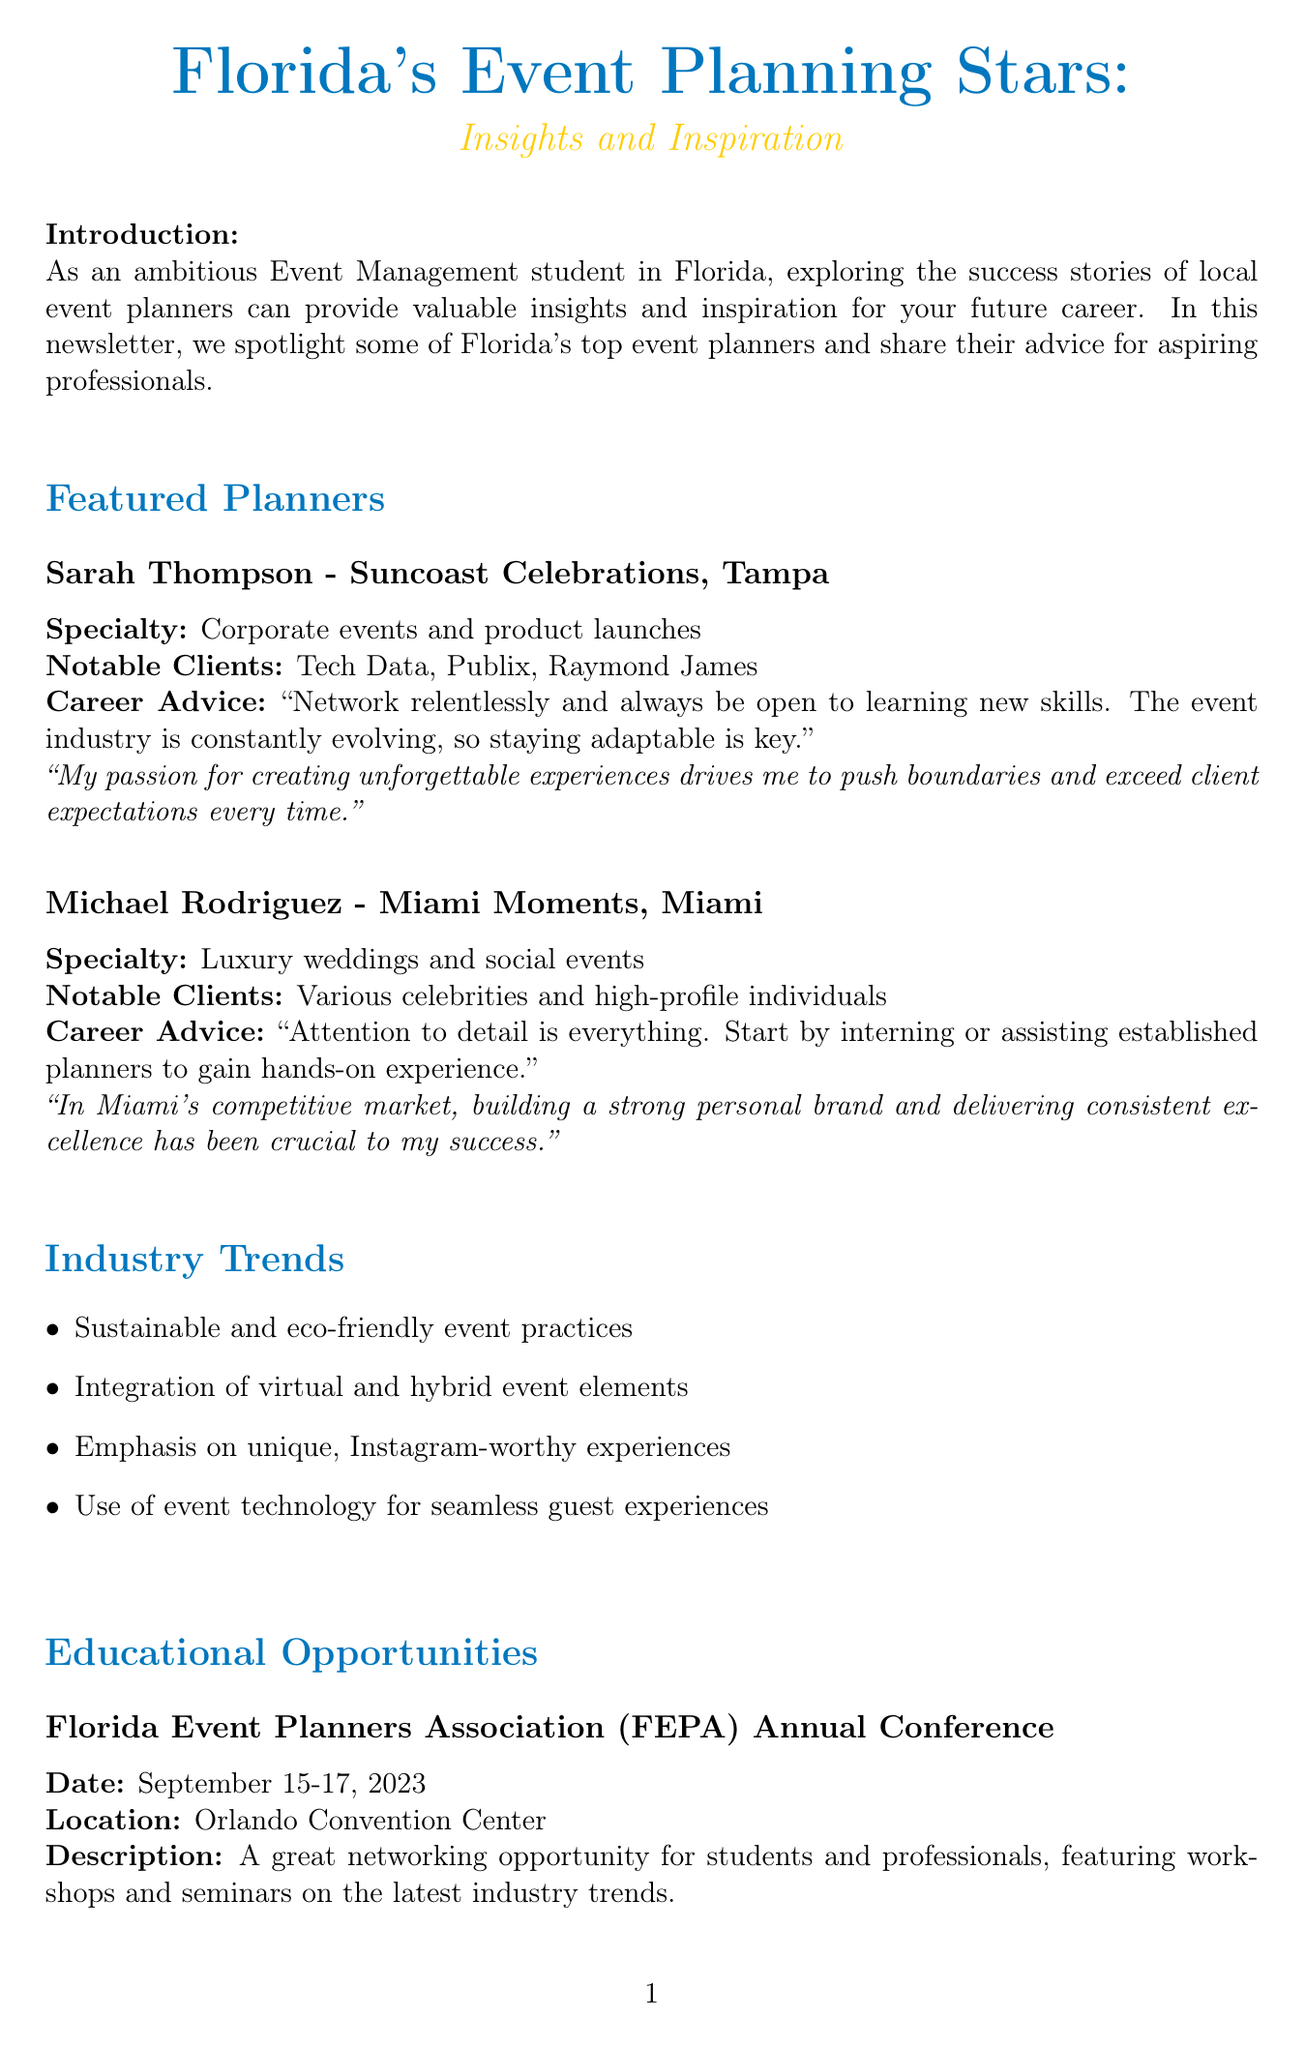What is the title of the newsletter? The title of the newsletter is provided at the beginning of the document.
Answer: Florida's Event Planning Stars: Insights and Inspiration Who is the owner of Suncoast Celebrations? The document specifies the owner of Suncoast Celebrations as Sarah Thompson.
Answer: Sarah Thompson What is Michael Rodriguez's specialty? The document lists Michael Rodriguez's specialty under his section.
Answer: Luxury weddings and social events When is the Florida Event Planners Association Annual Conference taking place? The date of the conference is explicitly mentioned in the educational opportunities section.
Answer: September 15-17, 2023 What key trend emphasizes unique experiences for social media? The document outlines several industry trends, one of which focuses on social media.
Answer: Emphasis on unique, Instagram-worthy experiences What advice does Sarah Thompson give about staying in the industry? The career advice given by Sarah Thompson can be found in her segment.
Answer: Network relentlessly and always be open to learning new skills Which website offers insights into Florida's tourism industry? The document lists the benefits of local resources, including their websites.
Answer: https://www.visitflorida.com/ What should students seek out as part of their studies according to the closing thoughts? The closing thoughts encourage students to take specific actions in their studies.
Answer: Internships 